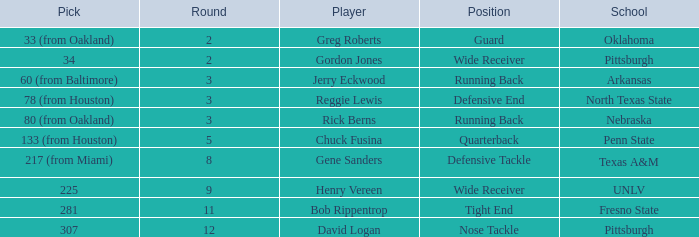What round was the nose tackle drafted? 12.0. 